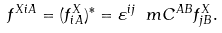Convert formula to latex. <formula><loc_0><loc_0><loc_500><loc_500>f ^ { X i A } = ( f ^ { X } _ { i A } ) ^ { * } = \varepsilon ^ { i j } \ m C ^ { A B } f ^ { X } _ { j B } .</formula> 